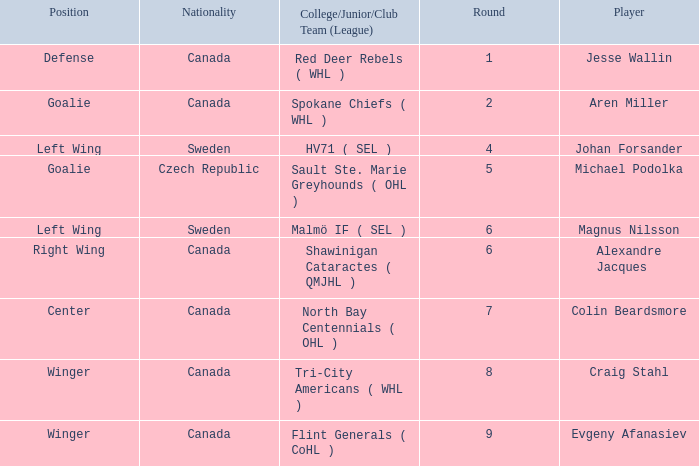What is the School/Junior/Club Group (Association) that has a Round bigger than 6, and a Place of winger, and a Player of evgeny afanasiev? Flint Generals ( CoHL ). 